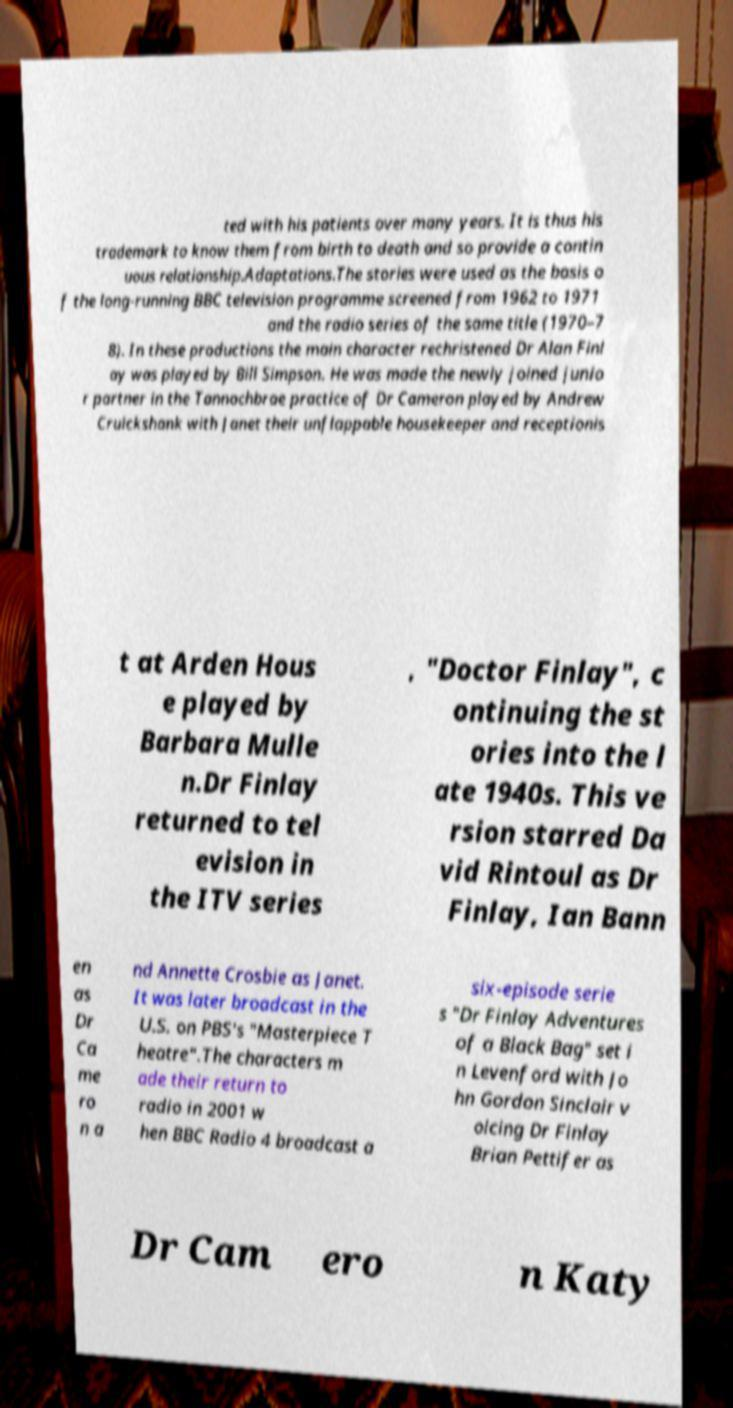Can you accurately transcribe the text from the provided image for me? ted with his patients over many years. It is thus his trademark to know them from birth to death and so provide a contin uous relationship.Adaptations.The stories were used as the basis o f the long-running BBC television programme screened from 1962 to 1971 and the radio series of the same title (1970–7 8). In these productions the main character rechristened Dr Alan Finl ay was played by Bill Simpson. He was made the newly joined junio r partner in the Tannochbrae practice of Dr Cameron played by Andrew Cruickshank with Janet their unflappable housekeeper and receptionis t at Arden Hous e played by Barbara Mulle n.Dr Finlay returned to tel evision in the ITV series , "Doctor Finlay", c ontinuing the st ories into the l ate 1940s. This ve rsion starred Da vid Rintoul as Dr Finlay, Ian Bann en as Dr Ca me ro n a nd Annette Crosbie as Janet. It was later broadcast in the U.S. on PBS's "Masterpiece T heatre".The characters m ade their return to radio in 2001 w hen BBC Radio 4 broadcast a six-episode serie s "Dr Finlay Adventures of a Black Bag" set i n Levenford with Jo hn Gordon Sinclair v oicing Dr Finlay Brian Pettifer as Dr Cam ero n Katy 